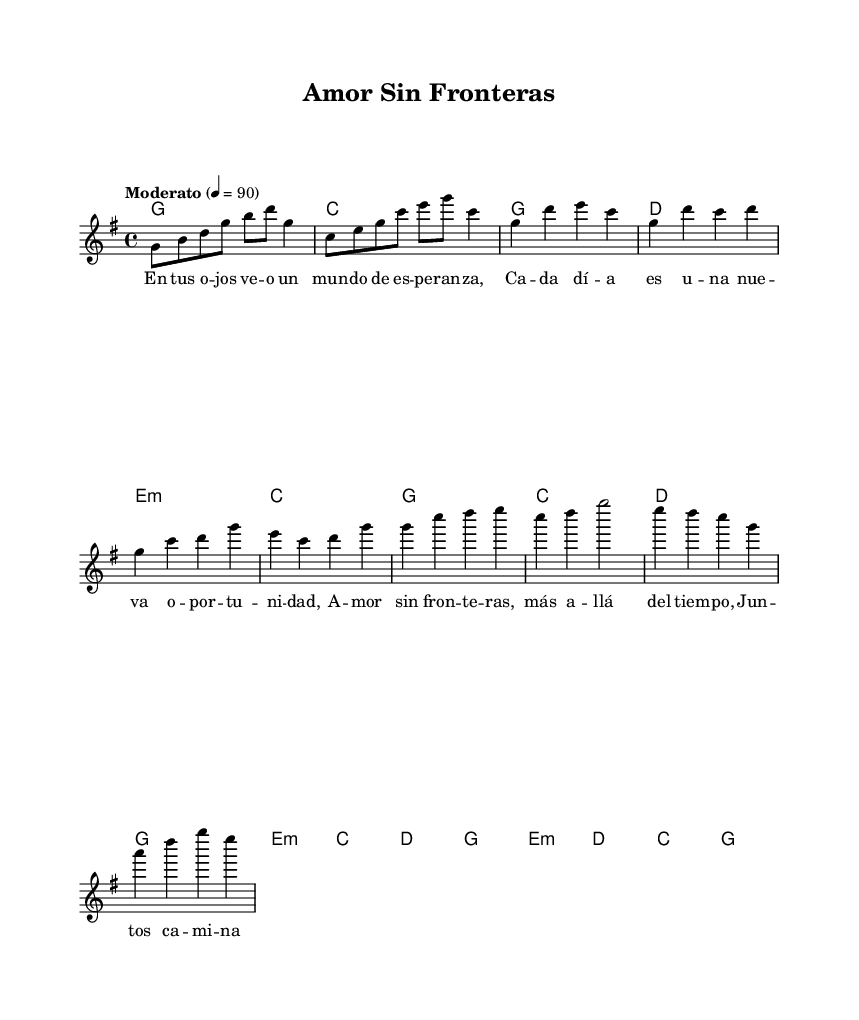What is the key signature of this music? The key signature of the music is G major, which features one sharp (F#). This can be identified from the key signature indicated at the beginning of the score under the treble clef.
Answer: G major What is the time signature of the piece? The time signature is 4/4, which is visible at the beginning of the score. This indicates that there are four beats per measure and a quarter note receives one beat.
Answer: 4/4 What is the tempo marking for this piece? The tempo marking is "Moderato," which means moderate speed. This is explicitly stated in the score next to the tempo indication at the beginning.
Answer: Moderato How many measures are there in the chorus section? The chorus section consists of four measures, which can be counted from the music notation starting from the beginning of the chorus lyrics until the end of that section.
Answer: Four What chords are used in the bridge of the piece? The chords used in the bridge are E minor, D, C, and G. This can be verified by looking at the chord changes listed above the staff during the bridge section of the music.
Answer: E minor, D, C, G What theme does this song primarily express? The song primarily expresses themes of parental love and family bonds, as indicated by the lyrics and the overall title of the piece "Amor Sin Fronteras," which translates to "Love Without Borders."
Answer: Love and family 